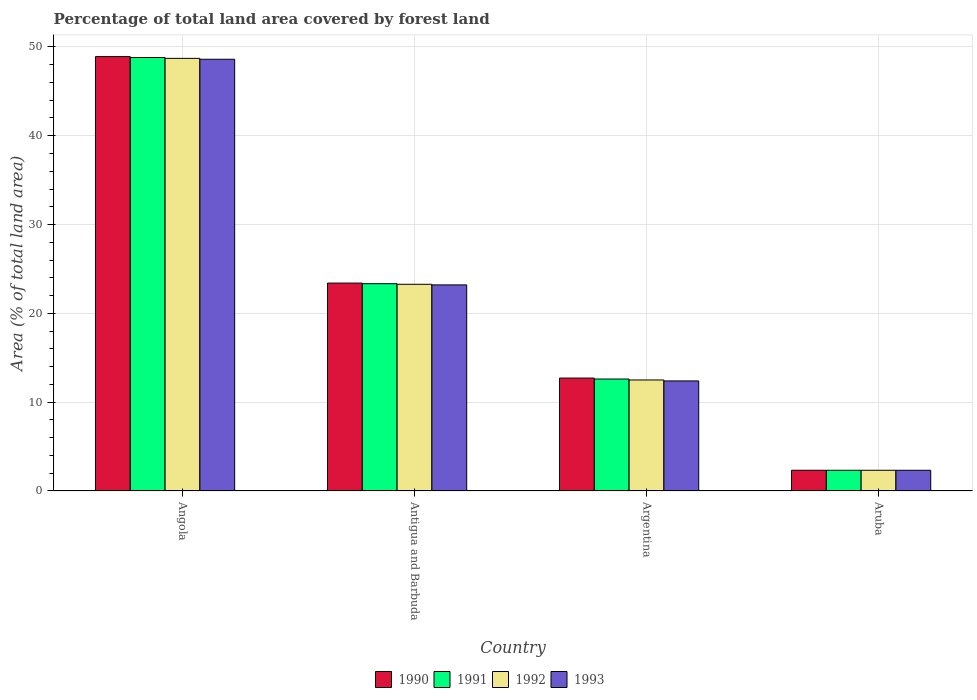How many different coloured bars are there?
Keep it short and to the point. 4. How many bars are there on the 1st tick from the left?
Offer a terse response. 4. How many bars are there on the 3rd tick from the right?
Provide a succinct answer. 4. What is the percentage of forest land in 1991 in Angola?
Provide a short and direct response. 48.81. Across all countries, what is the maximum percentage of forest land in 1991?
Provide a short and direct response. 48.81. Across all countries, what is the minimum percentage of forest land in 1990?
Offer a very short reply. 2.33. In which country was the percentage of forest land in 1993 maximum?
Offer a very short reply. Angola. In which country was the percentage of forest land in 1993 minimum?
Provide a short and direct response. Aruba. What is the total percentage of forest land in 1991 in the graph?
Your answer should be very brief. 87.09. What is the difference between the percentage of forest land in 1992 in Argentina and that in Aruba?
Give a very brief answer. 10.17. What is the difference between the percentage of forest land in 1990 in Aruba and the percentage of forest land in 1991 in Argentina?
Keep it short and to the point. -10.27. What is the average percentage of forest land in 1990 per country?
Offer a very short reply. 21.84. What is the difference between the percentage of forest land of/in 1993 and percentage of forest land of/in 1991 in Argentina?
Make the answer very short. -0.21. What is the ratio of the percentage of forest land in 1993 in Angola to that in Aruba?
Offer a terse response. 20.83. What is the difference between the highest and the second highest percentage of forest land in 1991?
Make the answer very short. 36.2. What is the difference between the highest and the lowest percentage of forest land in 1993?
Give a very brief answer. 46.28. Is it the case that in every country, the sum of the percentage of forest land in 1990 and percentage of forest land in 1992 is greater than the sum of percentage of forest land in 1993 and percentage of forest land in 1991?
Ensure brevity in your answer.  No. What does the 1st bar from the right in Angola represents?
Provide a short and direct response. 1993. How many bars are there?
Your answer should be compact. 16. Are all the bars in the graph horizontal?
Provide a succinct answer. No. Where does the legend appear in the graph?
Provide a short and direct response. Bottom center. How are the legend labels stacked?
Ensure brevity in your answer.  Horizontal. What is the title of the graph?
Your answer should be very brief. Percentage of total land area covered by forest land. Does "1961" appear as one of the legend labels in the graph?
Your answer should be compact. No. What is the label or title of the Y-axis?
Your answer should be compact. Area (% of total land area). What is the Area (% of total land area) in 1990 in Angola?
Offer a very short reply. 48.91. What is the Area (% of total land area) in 1991 in Angola?
Keep it short and to the point. 48.81. What is the Area (% of total land area) of 1992 in Angola?
Offer a terse response. 48.71. What is the Area (% of total land area) in 1993 in Angola?
Your answer should be very brief. 48.61. What is the Area (% of total land area) of 1990 in Antigua and Barbuda?
Your response must be concise. 23.41. What is the Area (% of total land area) in 1991 in Antigua and Barbuda?
Your response must be concise. 23.34. What is the Area (% of total land area) of 1992 in Antigua and Barbuda?
Give a very brief answer. 23.27. What is the Area (% of total land area) of 1993 in Antigua and Barbuda?
Provide a succinct answer. 23.2. What is the Area (% of total land area) in 1990 in Argentina?
Make the answer very short. 12.71. What is the Area (% of total land area) of 1991 in Argentina?
Provide a succinct answer. 12.61. What is the Area (% of total land area) of 1992 in Argentina?
Ensure brevity in your answer.  12.5. What is the Area (% of total land area) in 1993 in Argentina?
Make the answer very short. 12.39. What is the Area (% of total land area) in 1990 in Aruba?
Give a very brief answer. 2.33. What is the Area (% of total land area) in 1991 in Aruba?
Offer a terse response. 2.33. What is the Area (% of total land area) in 1992 in Aruba?
Keep it short and to the point. 2.33. What is the Area (% of total land area) of 1993 in Aruba?
Ensure brevity in your answer.  2.33. Across all countries, what is the maximum Area (% of total land area) of 1990?
Provide a succinct answer. 48.91. Across all countries, what is the maximum Area (% of total land area) of 1991?
Ensure brevity in your answer.  48.81. Across all countries, what is the maximum Area (% of total land area) of 1992?
Your answer should be compact. 48.71. Across all countries, what is the maximum Area (% of total land area) in 1993?
Make the answer very short. 48.61. Across all countries, what is the minimum Area (% of total land area) in 1990?
Ensure brevity in your answer.  2.33. Across all countries, what is the minimum Area (% of total land area) of 1991?
Provide a succinct answer. 2.33. Across all countries, what is the minimum Area (% of total land area) in 1992?
Give a very brief answer. 2.33. Across all countries, what is the minimum Area (% of total land area) in 1993?
Keep it short and to the point. 2.33. What is the total Area (% of total land area) of 1990 in the graph?
Give a very brief answer. 87.37. What is the total Area (% of total land area) in 1991 in the graph?
Offer a very short reply. 87.09. What is the total Area (% of total land area) of 1992 in the graph?
Make the answer very short. 86.81. What is the total Area (% of total land area) in 1993 in the graph?
Make the answer very short. 86.54. What is the difference between the Area (% of total land area) of 1990 in Angola and that in Antigua and Barbuda?
Give a very brief answer. 25.5. What is the difference between the Area (% of total land area) in 1991 in Angola and that in Antigua and Barbuda?
Provide a short and direct response. 25.47. What is the difference between the Area (% of total land area) in 1992 in Angola and that in Antigua and Barbuda?
Ensure brevity in your answer.  25.44. What is the difference between the Area (% of total land area) of 1993 in Angola and that in Antigua and Barbuda?
Make the answer very short. 25.41. What is the difference between the Area (% of total land area) in 1990 in Angola and that in Argentina?
Keep it short and to the point. 36.2. What is the difference between the Area (% of total land area) of 1991 in Angola and that in Argentina?
Give a very brief answer. 36.2. What is the difference between the Area (% of total land area) in 1992 in Angola and that in Argentina?
Make the answer very short. 36.21. What is the difference between the Area (% of total land area) of 1993 in Angola and that in Argentina?
Provide a short and direct response. 36.22. What is the difference between the Area (% of total land area) of 1990 in Angola and that in Aruba?
Your response must be concise. 46.58. What is the difference between the Area (% of total land area) of 1991 in Angola and that in Aruba?
Provide a succinct answer. 46.48. What is the difference between the Area (% of total land area) of 1992 in Angola and that in Aruba?
Your answer should be very brief. 46.38. What is the difference between the Area (% of total land area) of 1993 in Angola and that in Aruba?
Keep it short and to the point. 46.28. What is the difference between the Area (% of total land area) of 1990 in Antigua and Barbuda and that in Argentina?
Provide a succinct answer. 10.7. What is the difference between the Area (% of total land area) of 1991 in Antigua and Barbuda and that in Argentina?
Your answer should be compact. 10.73. What is the difference between the Area (% of total land area) in 1992 in Antigua and Barbuda and that in Argentina?
Offer a terse response. 10.77. What is the difference between the Area (% of total land area) of 1993 in Antigua and Barbuda and that in Argentina?
Offer a terse response. 10.81. What is the difference between the Area (% of total land area) of 1990 in Antigua and Barbuda and that in Aruba?
Provide a succinct answer. 21.08. What is the difference between the Area (% of total land area) in 1991 in Antigua and Barbuda and that in Aruba?
Your response must be concise. 21.01. What is the difference between the Area (% of total land area) in 1992 in Antigua and Barbuda and that in Aruba?
Provide a succinct answer. 20.94. What is the difference between the Area (% of total land area) of 1993 in Antigua and Barbuda and that in Aruba?
Ensure brevity in your answer.  20.87. What is the difference between the Area (% of total land area) in 1990 in Argentina and that in Aruba?
Offer a very short reply. 10.38. What is the difference between the Area (% of total land area) in 1991 in Argentina and that in Aruba?
Offer a terse response. 10.27. What is the difference between the Area (% of total land area) of 1992 in Argentina and that in Aruba?
Offer a very short reply. 10.17. What is the difference between the Area (% of total land area) of 1993 in Argentina and that in Aruba?
Your answer should be very brief. 10.06. What is the difference between the Area (% of total land area) of 1990 in Angola and the Area (% of total land area) of 1991 in Antigua and Barbuda?
Offer a terse response. 25.57. What is the difference between the Area (% of total land area) of 1990 in Angola and the Area (% of total land area) of 1992 in Antigua and Barbuda?
Offer a very short reply. 25.64. What is the difference between the Area (% of total land area) in 1990 in Angola and the Area (% of total land area) in 1993 in Antigua and Barbuda?
Ensure brevity in your answer.  25.71. What is the difference between the Area (% of total land area) of 1991 in Angola and the Area (% of total land area) of 1992 in Antigua and Barbuda?
Offer a terse response. 25.54. What is the difference between the Area (% of total land area) in 1991 in Angola and the Area (% of total land area) in 1993 in Antigua and Barbuda?
Offer a very short reply. 25.61. What is the difference between the Area (% of total land area) in 1992 in Angola and the Area (% of total land area) in 1993 in Antigua and Barbuda?
Offer a terse response. 25.51. What is the difference between the Area (% of total land area) of 1990 in Angola and the Area (% of total land area) of 1991 in Argentina?
Offer a very short reply. 36.3. What is the difference between the Area (% of total land area) of 1990 in Angola and the Area (% of total land area) of 1992 in Argentina?
Provide a short and direct response. 36.41. What is the difference between the Area (% of total land area) of 1990 in Angola and the Area (% of total land area) of 1993 in Argentina?
Provide a succinct answer. 36.52. What is the difference between the Area (% of total land area) of 1991 in Angola and the Area (% of total land area) of 1992 in Argentina?
Offer a very short reply. 36.31. What is the difference between the Area (% of total land area) of 1991 in Angola and the Area (% of total land area) of 1993 in Argentina?
Offer a very short reply. 36.42. What is the difference between the Area (% of total land area) in 1992 in Angola and the Area (% of total land area) in 1993 in Argentina?
Give a very brief answer. 36.32. What is the difference between the Area (% of total land area) in 1990 in Angola and the Area (% of total land area) in 1991 in Aruba?
Offer a terse response. 46.58. What is the difference between the Area (% of total land area) of 1990 in Angola and the Area (% of total land area) of 1992 in Aruba?
Your response must be concise. 46.58. What is the difference between the Area (% of total land area) in 1990 in Angola and the Area (% of total land area) in 1993 in Aruba?
Your answer should be very brief. 46.58. What is the difference between the Area (% of total land area) of 1991 in Angola and the Area (% of total land area) of 1992 in Aruba?
Your response must be concise. 46.48. What is the difference between the Area (% of total land area) of 1991 in Angola and the Area (% of total land area) of 1993 in Aruba?
Make the answer very short. 46.48. What is the difference between the Area (% of total land area) of 1992 in Angola and the Area (% of total land area) of 1993 in Aruba?
Offer a terse response. 46.38. What is the difference between the Area (% of total land area) of 1990 in Antigua and Barbuda and the Area (% of total land area) of 1991 in Argentina?
Your answer should be very brief. 10.8. What is the difference between the Area (% of total land area) in 1990 in Antigua and Barbuda and the Area (% of total land area) in 1992 in Argentina?
Make the answer very short. 10.91. What is the difference between the Area (% of total land area) of 1990 in Antigua and Barbuda and the Area (% of total land area) of 1993 in Argentina?
Offer a very short reply. 11.02. What is the difference between the Area (% of total land area) in 1991 in Antigua and Barbuda and the Area (% of total land area) in 1992 in Argentina?
Provide a short and direct response. 10.84. What is the difference between the Area (% of total land area) in 1991 in Antigua and Barbuda and the Area (% of total land area) in 1993 in Argentina?
Your response must be concise. 10.95. What is the difference between the Area (% of total land area) of 1992 in Antigua and Barbuda and the Area (% of total land area) of 1993 in Argentina?
Your answer should be very brief. 10.88. What is the difference between the Area (% of total land area) of 1990 in Antigua and Barbuda and the Area (% of total land area) of 1991 in Aruba?
Keep it short and to the point. 21.08. What is the difference between the Area (% of total land area) of 1990 in Antigua and Barbuda and the Area (% of total land area) of 1992 in Aruba?
Offer a very short reply. 21.08. What is the difference between the Area (% of total land area) in 1990 in Antigua and Barbuda and the Area (% of total land area) in 1993 in Aruba?
Your response must be concise. 21.08. What is the difference between the Area (% of total land area) in 1991 in Antigua and Barbuda and the Area (% of total land area) in 1992 in Aruba?
Ensure brevity in your answer.  21.01. What is the difference between the Area (% of total land area) of 1991 in Antigua and Barbuda and the Area (% of total land area) of 1993 in Aruba?
Provide a short and direct response. 21.01. What is the difference between the Area (% of total land area) of 1992 in Antigua and Barbuda and the Area (% of total land area) of 1993 in Aruba?
Offer a terse response. 20.94. What is the difference between the Area (% of total land area) of 1990 in Argentina and the Area (% of total land area) of 1991 in Aruba?
Offer a very short reply. 10.38. What is the difference between the Area (% of total land area) in 1990 in Argentina and the Area (% of total land area) in 1992 in Aruba?
Ensure brevity in your answer.  10.38. What is the difference between the Area (% of total land area) in 1990 in Argentina and the Area (% of total land area) in 1993 in Aruba?
Make the answer very short. 10.38. What is the difference between the Area (% of total land area) in 1991 in Argentina and the Area (% of total land area) in 1992 in Aruba?
Give a very brief answer. 10.27. What is the difference between the Area (% of total land area) of 1991 in Argentina and the Area (% of total land area) of 1993 in Aruba?
Make the answer very short. 10.27. What is the difference between the Area (% of total land area) of 1992 in Argentina and the Area (% of total land area) of 1993 in Aruba?
Your answer should be compact. 10.17. What is the average Area (% of total land area) of 1990 per country?
Provide a short and direct response. 21.84. What is the average Area (% of total land area) in 1991 per country?
Offer a very short reply. 21.77. What is the average Area (% of total land area) in 1992 per country?
Offer a very short reply. 21.7. What is the average Area (% of total land area) in 1993 per country?
Provide a succinct answer. 21.63. What is the difference between the Area (% of total land area) in 1990 and Area (% of total land area) in 1991 in Angola?
Make the answer very short. 0.1. What is the difference between the Area (% of total land area) of 1990 and Area (% of total land area) of 1992 in Angola?
Your response must be concise. 0.2. What is the difference between the Area (% of total land area) in 1990 and Area (% of total land area) in 1993 in Angola?
Offer a terse response. 0.3. What is the difference between the Area (% of total land area) of 1991 and Area (% of total land area) of 1992 in Angola?
Offer a very short reply. 0.1. What is the difference between the Area (% of total land area) of 1991 and Area (% of total land area) of 1993 in Angola?
Keep it short and to the point. 0.2. What is the difference between the Area (% of total land area) in 1992 and Area (% of total land area) in 1993 in Angola?
Provide a short and direct response. 0.1. What is the difference between the Area (% of total land area) of 1990 and Area (% of total land area) of 1991 in Antigua and Barbuda?
Make the answer very short. 0.07. What is the difference between the Area (% of total land area) of 1990 and Area (% of total land area) of 1992 in Antigua and Barbuda?
Ensure brevity in your answer.  0.14. What is the difference between the Area (% of total land area) of 1990 and Area (% of total land area) of 1993 in Antigua and Barbuda?
Give a very brief answer. 0.2. What is the difference between the Area (% of total land area) of 1991 and Area (% of total land area) of 1992 in Antigua and Barbuda?
Provide a succinct answer. 0.07. What is the difference between the Area (% of total land area) in 1991 and Area (% of total land area) in 1993 in Antigua and Barbuda?
Offer a very short reply. 0.14. What is the difference between the Area (% of total land area) in 1992 and Area (% of total land area) in 1993 in Antigua and Barbuda?
Your response must be concise. 0.07. What is the difference between the Area (% of total land area) in 1990 and Area (% of total land area) in 1991 in Argentina?
Offer a very short reply. 0.11. What is the difference between the Area (% of total land area) of 1990 and Area (% of total land area) of 1992 in Argentina?
Offer a very short reply. 0.21. What is the difference between the Area (% of total land area) in 1990 and Area (% of total land area) in 1993 in Argentina?
Make the answer very short. 0.32. What is the difference between the Area (% of total land area) of 1991 and Area (% of total land area) of 1992 in Argentina?
Offer a very short reply. 0.11. What is the difference between the Area (% of total land area) in 1991 and Area (% of total land area) in 1993 in Argentina?
Give a very brief answer. 0.21. What is the difference between the Area (% of total land area) in 1992 and Area (% of total land area) in 1993 in Argentina?
Provide a short and direct response. 0.11. What is the difference between the Area (% of total land area) of 1990 and Area (% of total land area) of 1992 in Aruba?
Keep it short and to the point. 0. What is the ratio of the Area (% of total land area) of 1990 in Angola to that in Antigua and Barbuda?
Your answer should be very brief. 2.09. What is the ratio of the Area (% of total land area) of 1991 in Angola to that in Antigua and Barbuda?
Your answer should be compact. 2.09. What is the ratio of the Area (% of total land area) in 1992 in Angola to that in Antigua and Barbuda?
Provide a short and direct response. 2.09. What is the ratio of the Area (% of total land area) in 1993 in Angola to that in Antigua and Barbuda?
Give a very brief answer. 2.09. What is the ratio of the Area (% of total land area) in 1990 in Angola to that in Argentina?
Offer a terse response. 3.85. What is the ratio of the Area (% of total land area) in 1991 in Angola to that in Argentina?
Ensure brevity in your answer.  3.87. What is the ratio of the Area (% of total land area) in 1992 in Angola to that in Argentina?
Give a very brief answer. 3.9. What is the ratio of the Area (% of total land area) of 1993 in Angola to that in Argentina?
Keep it short and to the point. 3.92. What is the ratio of the Area (% of total land area) of 1990 in Angola to that in Aruba?
Give a very brief answer. 20.96. What is the ratio of the Area (% of total land area) of 1991 in Angola to that in Aruba?
Your response must be concise. 20.92. What is the ratio of the Area (% of total land area) in 1992 in Angola to that in Aruba?
Your response must be concise. 20.88. What is the ratio of the Area (% of total land area) of 1993 in Angola to that in Aruba?
Keep it short and to the point. 20.83. What is the ratio of the Area (% of total land area) in 1990 in Antigua and Barbuda to that in Argentina?
Make the answer very short. 1.84. What is the ratio of the Area (% of total land area) in 1991 in Antigua and Barbuda to that in Argentina?
Offer a terse response. 1.85. What is the ratio of the Area (% of total land area) of 1992 in Antigua and Barbuda to that in Argentina?
Your answer should be compact. 1.86. What is the ratio of the Area (% of total land area) in 1993 in Antigua and Barbuda to that in Argentina?
Provide a short and direct response. 1.87. What is the ratio of the Area (% of total land area) of 1990 in Antigua and Barbuda to that in Aruba?
Give a very brief answer. 10.03. What is the ratio of the Area (% of total land area) of 1991 in Antigua and Barbuda to that in Aruba?
Keep it short and to the point. 10. What is the ratio of the Area (% of total land area) of 1992 in Antigua and Barbuda to that in Aruba?
Keep it short and to the point. 9.97. What is the ratio of the Area (% of total land area) in 1993 in Antigua and Barbuda to that in Aruba?
Your answer should be very brief. 9.94. What is the ratio of the Area (% of total land area) of 1990 in Argentina to that in Aruba?
Make the answer very short. 5.45. What is the ratio of the Area (% of total land area) in 1991 in Argentina to that in Aruba?
Give a very brief answer. 5.4. What is the ratio of the Area (% of total land area) of 1992 in Argentina to that in Aruba?
Ensure brevity in your answer.  5.36. What is the ratio of the Area (% of total land area) of 1993 in Argentina to that in Aruba?
Give a very brief answer. 5.31. What is the difference between the highest and the second highest Area (% of total land area) in 1990?
Ensure brevity in your answer.  25.5. What is the difference between the highest and the second highest Area (% of total land area) in 1991?
Provide a succinct answer. 25.47. What is the difference between the highest and the second highest Area (% of total land area) in 1992?
Provide a short and direct response. 25.44. What is the difference between the highest and the second highest Area (% of total land area) of 1993?
Make the answer very short. 25.41. What is the difference between the highest and the lowest Area (% of total land area) of 1990?
Give a very brief answer. 46.58. What is the difference between the highest and the lowest Area (% of total land area) of 1991?
Your answer should be compact. 46.48. What is the difference between the highest and the lowest Area (% of total land area) in 1992?
Your answer should be very brief. 46.38. What is the difference between the highest and the lowest Area (% of total land area) of 1993?
Your answer should be very brief. 46.28. 